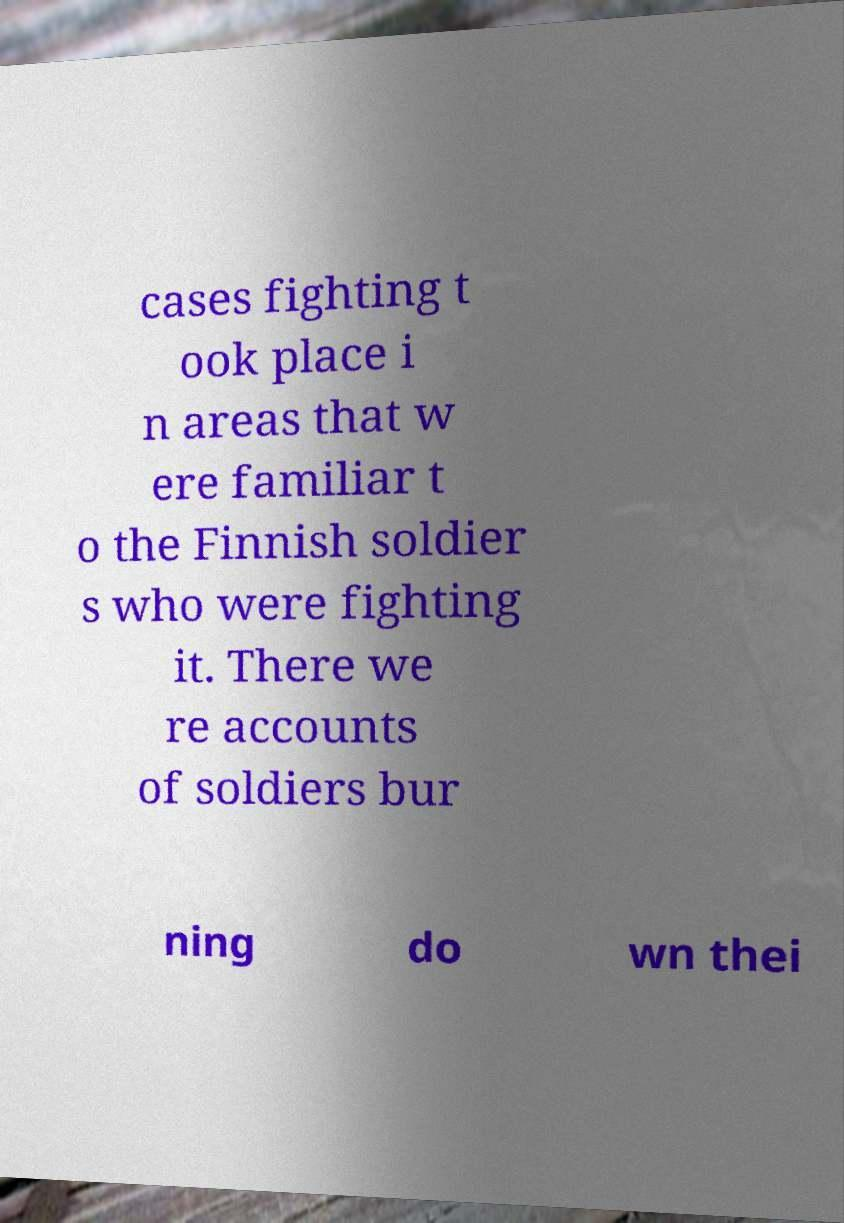Can you read and provide the text displayed in the image?This photo seems to have some interesting text. Can you extract and type it out for me? cases fighting t ook place i n areas that w ere familiar t o the Finnish soldier s who were fighting it. There we re accounts of soldiers bur ning do wn thei 